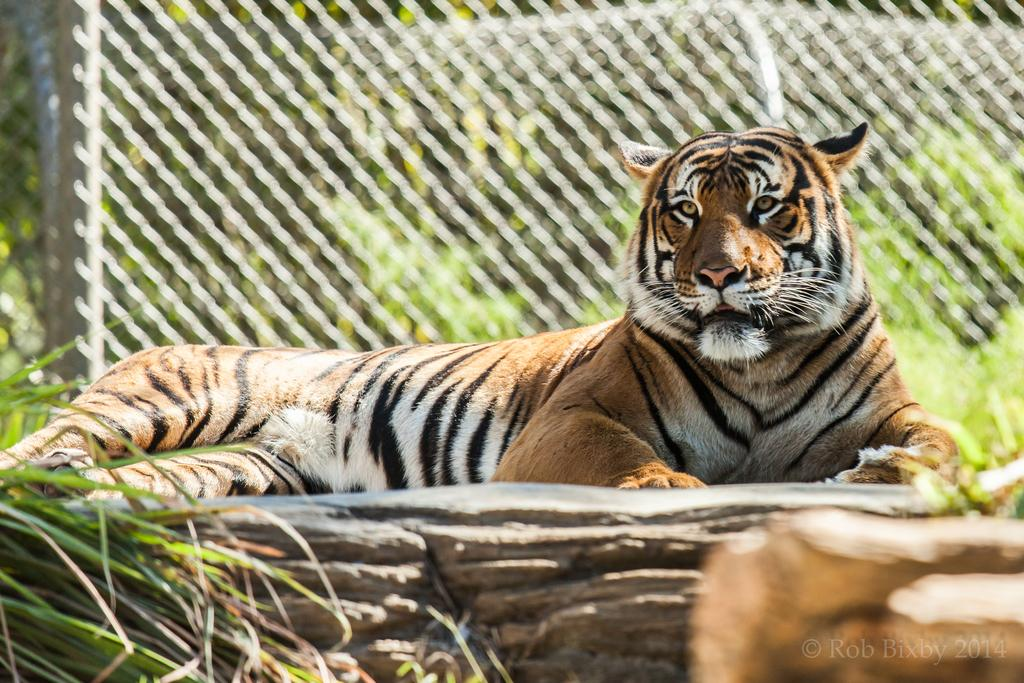What animal is sitting on a rock in the image? There is a tiger sitting on a rock in the image. What type of vegetation is visible at the bottom left of the image? There is grass in the left bottom of the image. What can be seen in the background of the image? There is a fence and trees present in the background of the image. What other type of vegetation is visible in the background of the image? There are plants in the background of the image. How does the tiger participate in the competition in the image? There is no competition present in the image; it is a tiger sitting on a rock with grass, a fence, trees, and plants in the background. 